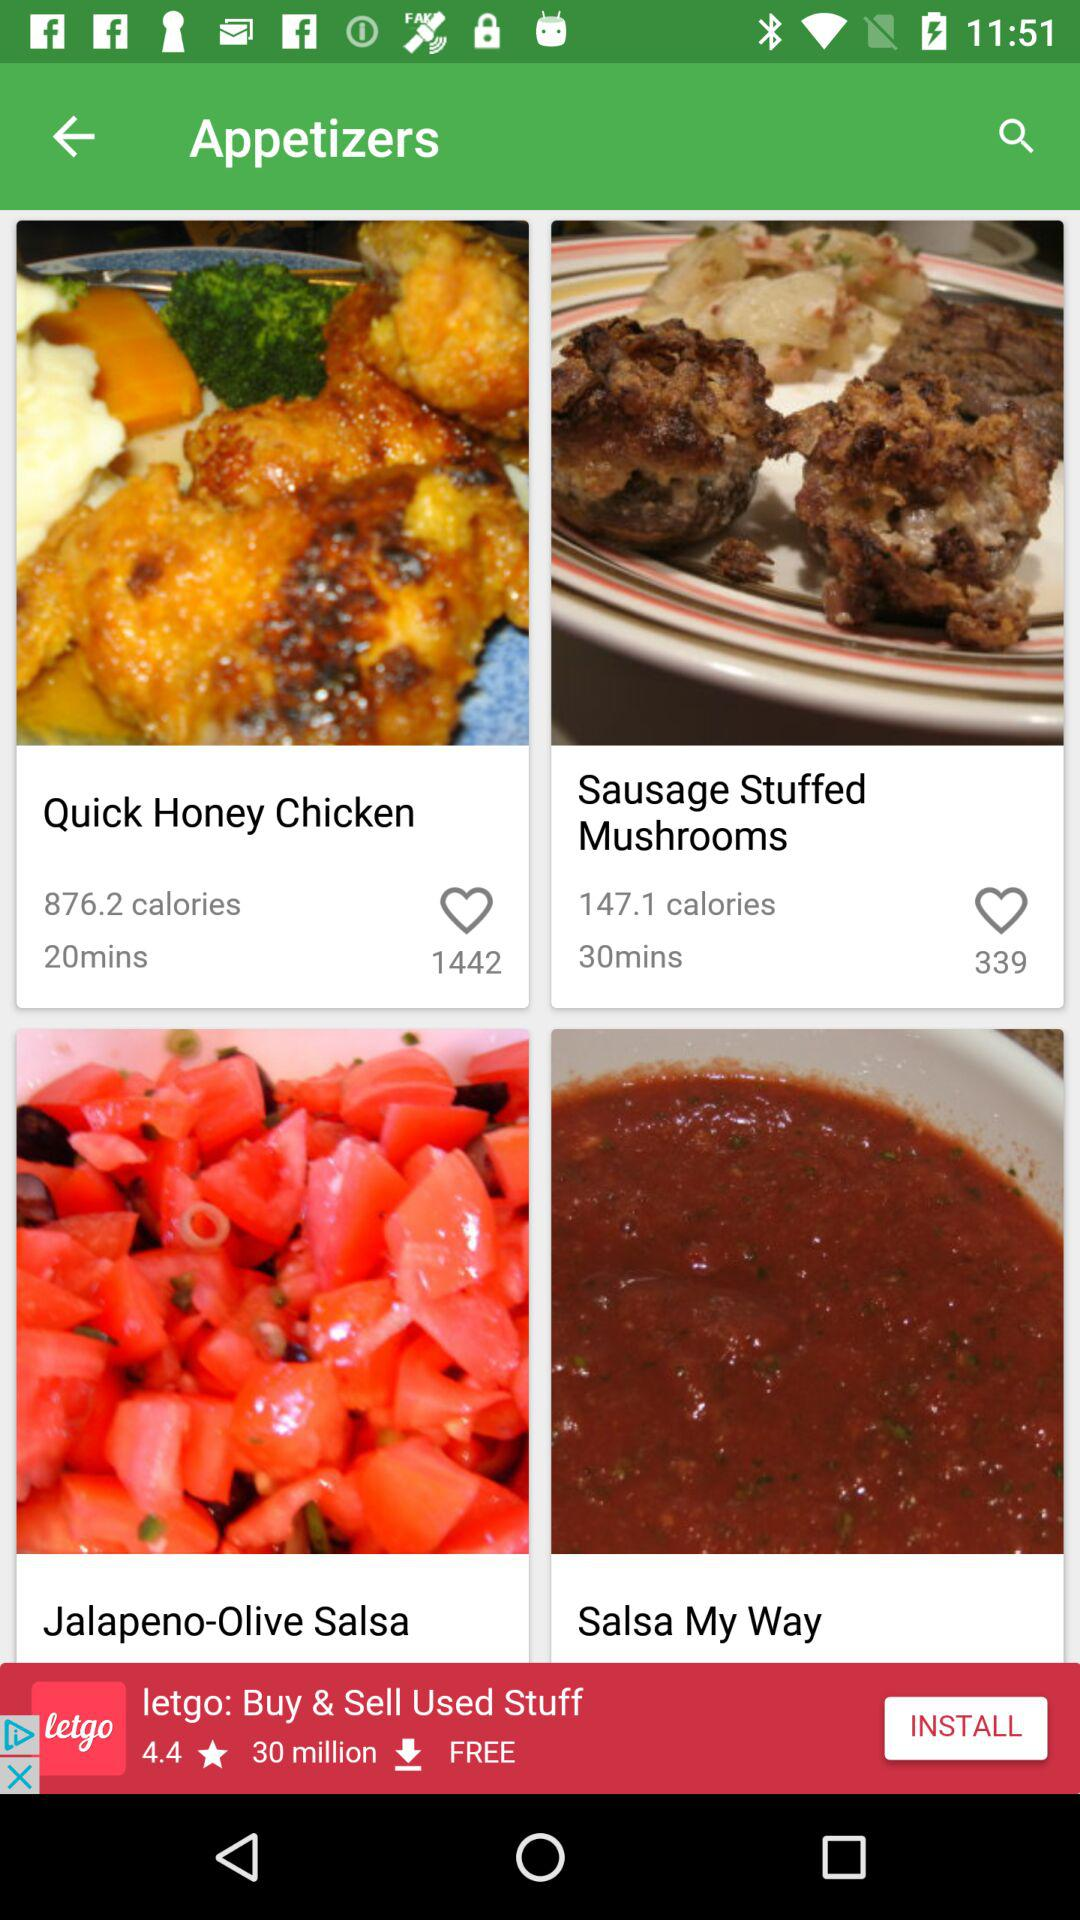How much time is taken to prepare a quick honey chicken? The time taken is 20 minutes. 